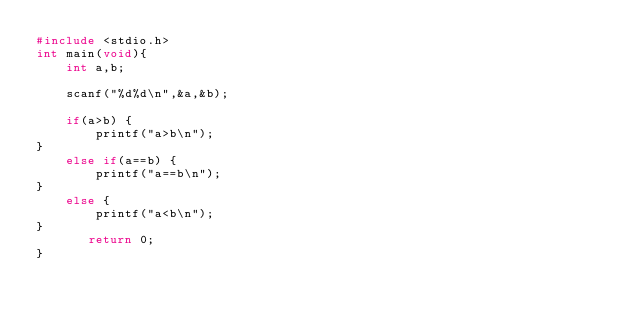Convert code to text. <code><loc_0><loc_0><loc_500><loc_500><_C_>#include <stdio.h>
int main(void){
    int a,b;
    
    scanf("%d%d\n",&a,&b);
    
    if(a>b) {
        printf("a>b\n");
}
    else if(a==b) {
        printf("a==b\n");
}
    else {
        printf("a<b\n");
}
       return 0;
}</code> 